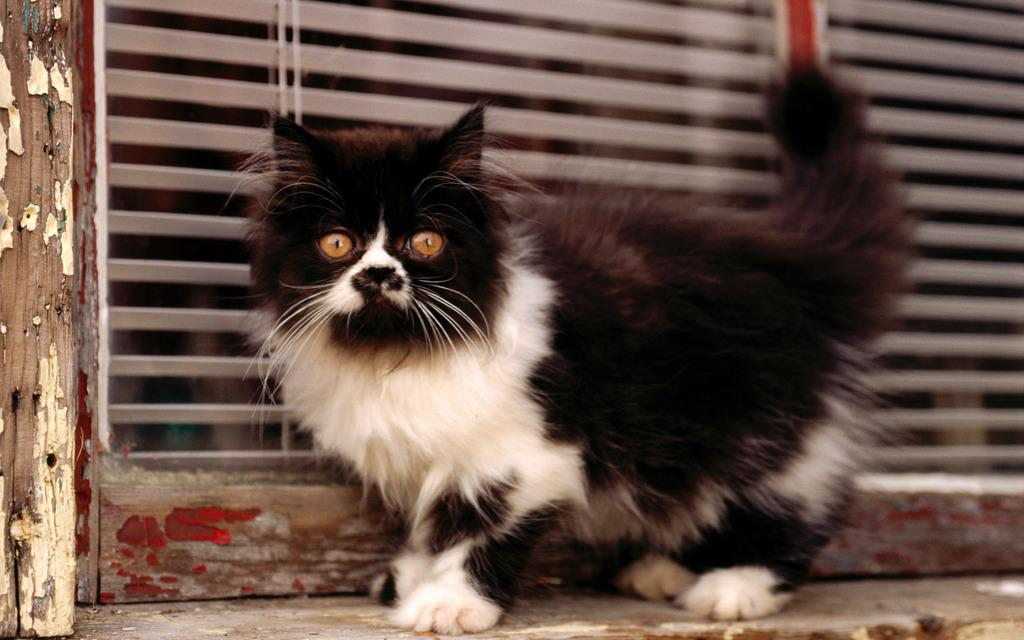What type of animal is in the image? There is a cat in the image. What is located behind the cat in the image? There is a door or window behind the cat in the image. What type of body of water can be seen in the image? There is no body of water present in the image; it features a cat and a door or window. What type of turkey is visible in the image? There is no turkey present in the image; it features a cat and a door or window. 